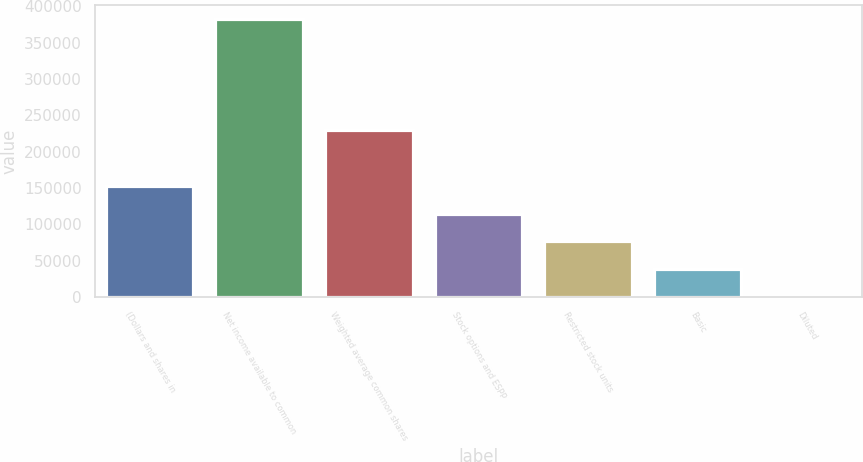Convert chart to OTSL. <chart><loc_0><loc_0><loc_500><loc_500><bar_chart><fcel>(Dollars and shares in<fcel>Net income available to common<fcel>Weighted average common shares<fcel>Stock options and ESPP<fcel>Restricted stock units<fcel>Basic<fcel>Diluted<nl><fcel>153078<fcel>382685<fcel>229614<fcel>114811<fcel>76542.9<fcel>38275.1<fcel>7.31<nl></chart> 